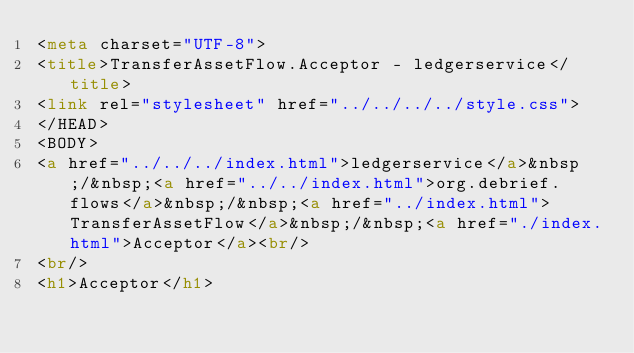Convert code to text. <code><loc_0><loc_0><loc_500><loc_500><_HTML_><meta charset="UTF-8">
<title>TransferAssetFlow.Acceptor - ledgerservice</title>
<link rel="stylesheet" href="../../../../style.css">
</HEAD>
<BODY>
<a href="../../../index.html">ledgerservice</a>&nbsp;/&nbsp;<a href="../../index.html">org.debrief.flows</a>&nbsp;/&nbsp;<a href="../index.html">TransferAssetFlow</a>&nbsp;/&nbsp;<a href="./index.html">Acceptor</a><br/>
<br/>
<h1>Acceptor</h1></code> 